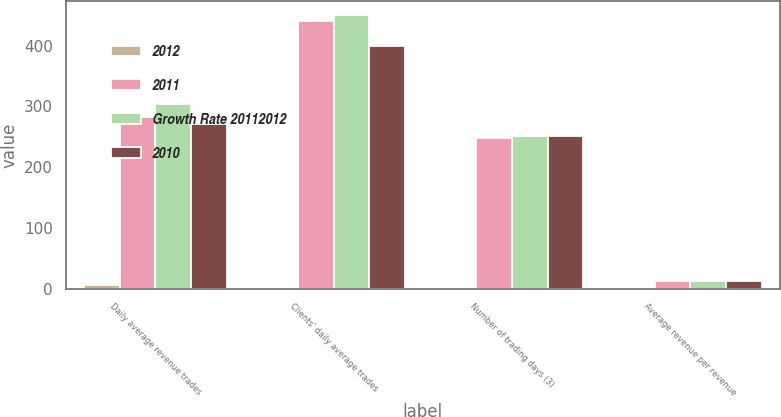Convert chart. <chart><loc_0><loc_0><loc_500><loc_500><stacked_bar_chart><ecel><fcel>Daily average revenue trades<fcel>Clients' daily average trades<fcel>Number of trading days (3)<fcel>Average revenue per revenue<nl><fcel>2012<fcel>7<fcel>2<fcel>1<fcel>2<nl><fcel>2011<fcel>282.7<fcel>440.9<fcel>248.5<fcel>12.35<nl><fcel>Growth Rate 20112012<fcel>303.8<fcel>451.1<fcel>251.5<fcel>12.15<nl><fcel>2010<fcel>270.7<fcel>399.7<fcel>251.5<fcel>12.28<nl></chart> 